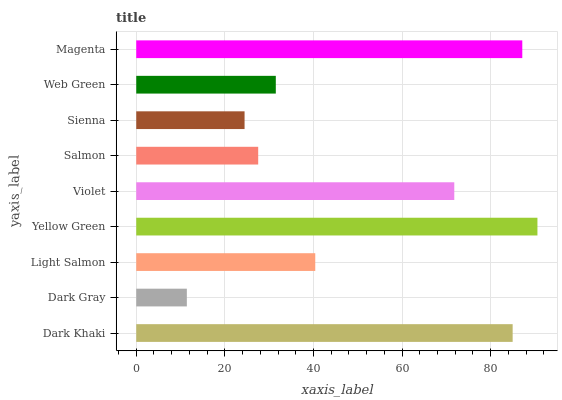Is Dark Gray the minimum?
Answer yes or no. Yes. Is Yellow Green the maximum?
Answer yes or no. Yes. Is Light Salmon the minimum?
Answer yes or no. No. Is Light Salmon the maximum?
Answer yes or no. No. Is Light Salmon greater than Dark Gray?
Answer yes or no. Yes. Is Dark Gray less than Light Salmon?
Answer yes or no. Yes. Is Dark Gray greater than Light Salmon?
Answer yes or no. No. Is Light Salmon less than Dark Gray?
Answer yes or no. No. Is Light Salmon the high median?
Answer yes or no. Yes. Is Light Salmon the low median?
Answer yes or no. Yes. Is Magenta the high median?
Answer yes or no. No. Is Violet the low median?
Answer yes or no. No. 